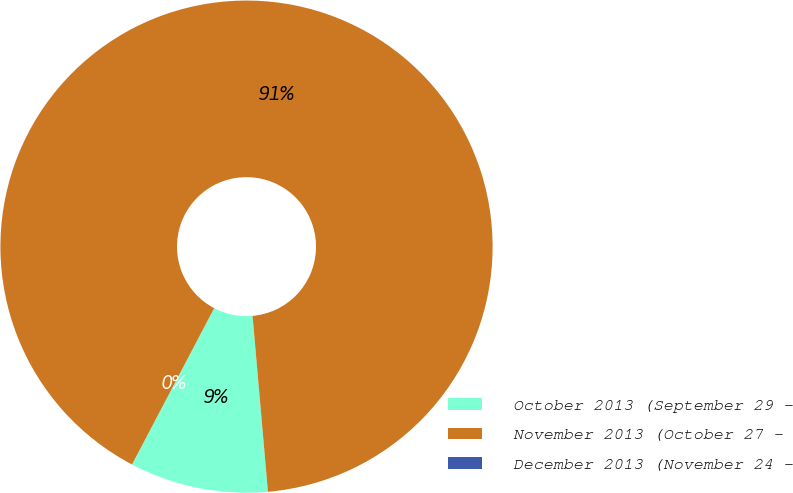Convert chart to OTSL. <chart><loc_0><loc_0><loc_500><loc_500><pie_chart><fcel>October 2013 (September 29 -<fcel>November 2013 (October 27 -<fcel>December 2013 (November 24 -<nl><fcel>9.09%<fcel>90.91%<fcel>0.0%<nl></chart> 